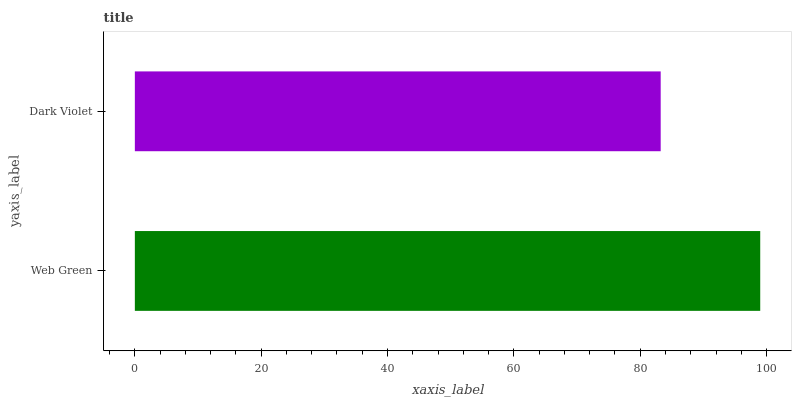Is Dark Violet the minimum?
Answer yes or no. Yes. Is Web Green the maximum?
Answer yes or no. Yes. Is Dark Violet the maximum?
Answer yes or no. No. Is Web Green greater than Dark Violet?
Answer yes or no. Yes. Is Dark Violet less than Web Green?
Answer yes or no. Yes. Is Dark Violet greater than Web Green?
Answer yes or no. No. Is Web Green less than Dark Violet?
Answer yes or no. No. Is Web Green the high median?
Answer yes or no. Yes. Is Dark Violet the low median?
Answer yes or no. Yes. Is Dark Violet the high median?
Answer yes or no. No. Is Web Green the low median?
Answer yes or no. No. 